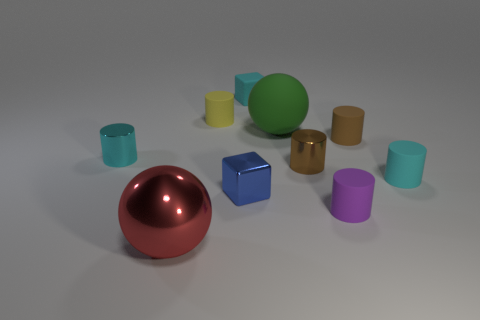Subtract all brown rubber cylinders. How many cylinders are left? 5 Subtract all purple cylinders. How many cylinders are left? 5 Subtract all red cylinders. Subtract all purple spheres. How many cylinders are left? 6 Subtract all blocks. How many objects are left? 8 Add 2 tiny green metal balls. How many tiny green metal balls exist? 2 Subtract 1 brown cylinders. How many objects are left? 9 Subtract all big green matte spheres. Subtract all big matte objects. How many objects are left? 8 Add 5 tiny purple matte objects. How many tiny purple matte objects are left? 6 